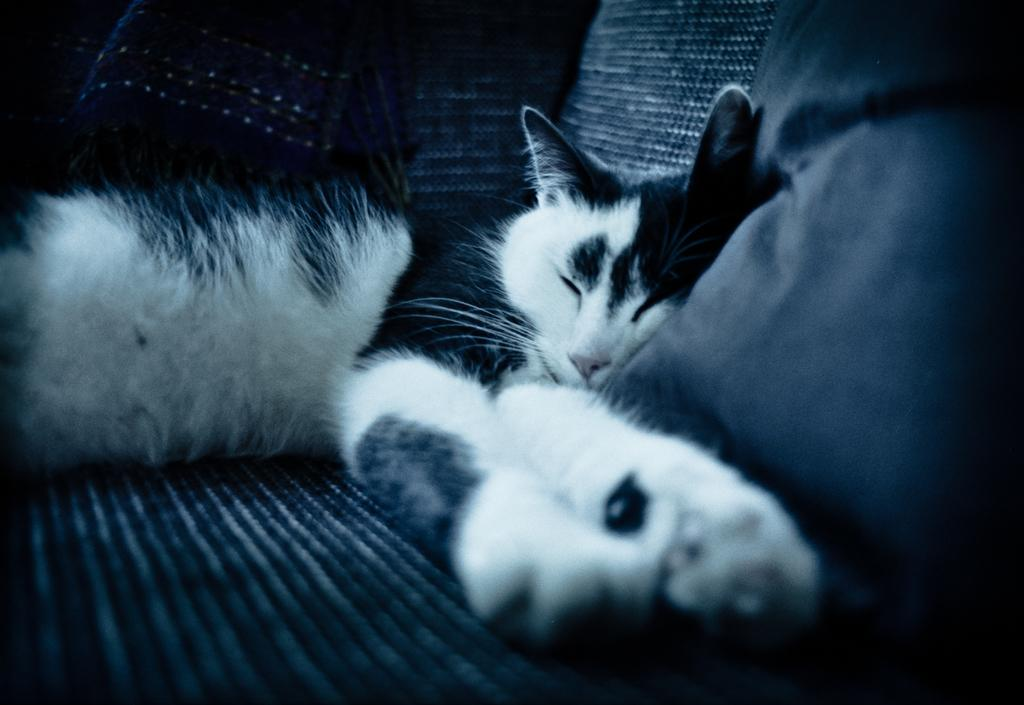What type of animal is in the picture? There is a cat in the picture. What is the cat doing in the picture? The cat is sleeping. Where is the cat located in the picture? The cat is on a sofa. What can be seen in the right corner of the image? There is a pillow in the right corner of the image. How many times does the cat touch its nose in the image? There is no indication in the image that the cat is touching its nose, so it cannot be determined from the picture. 